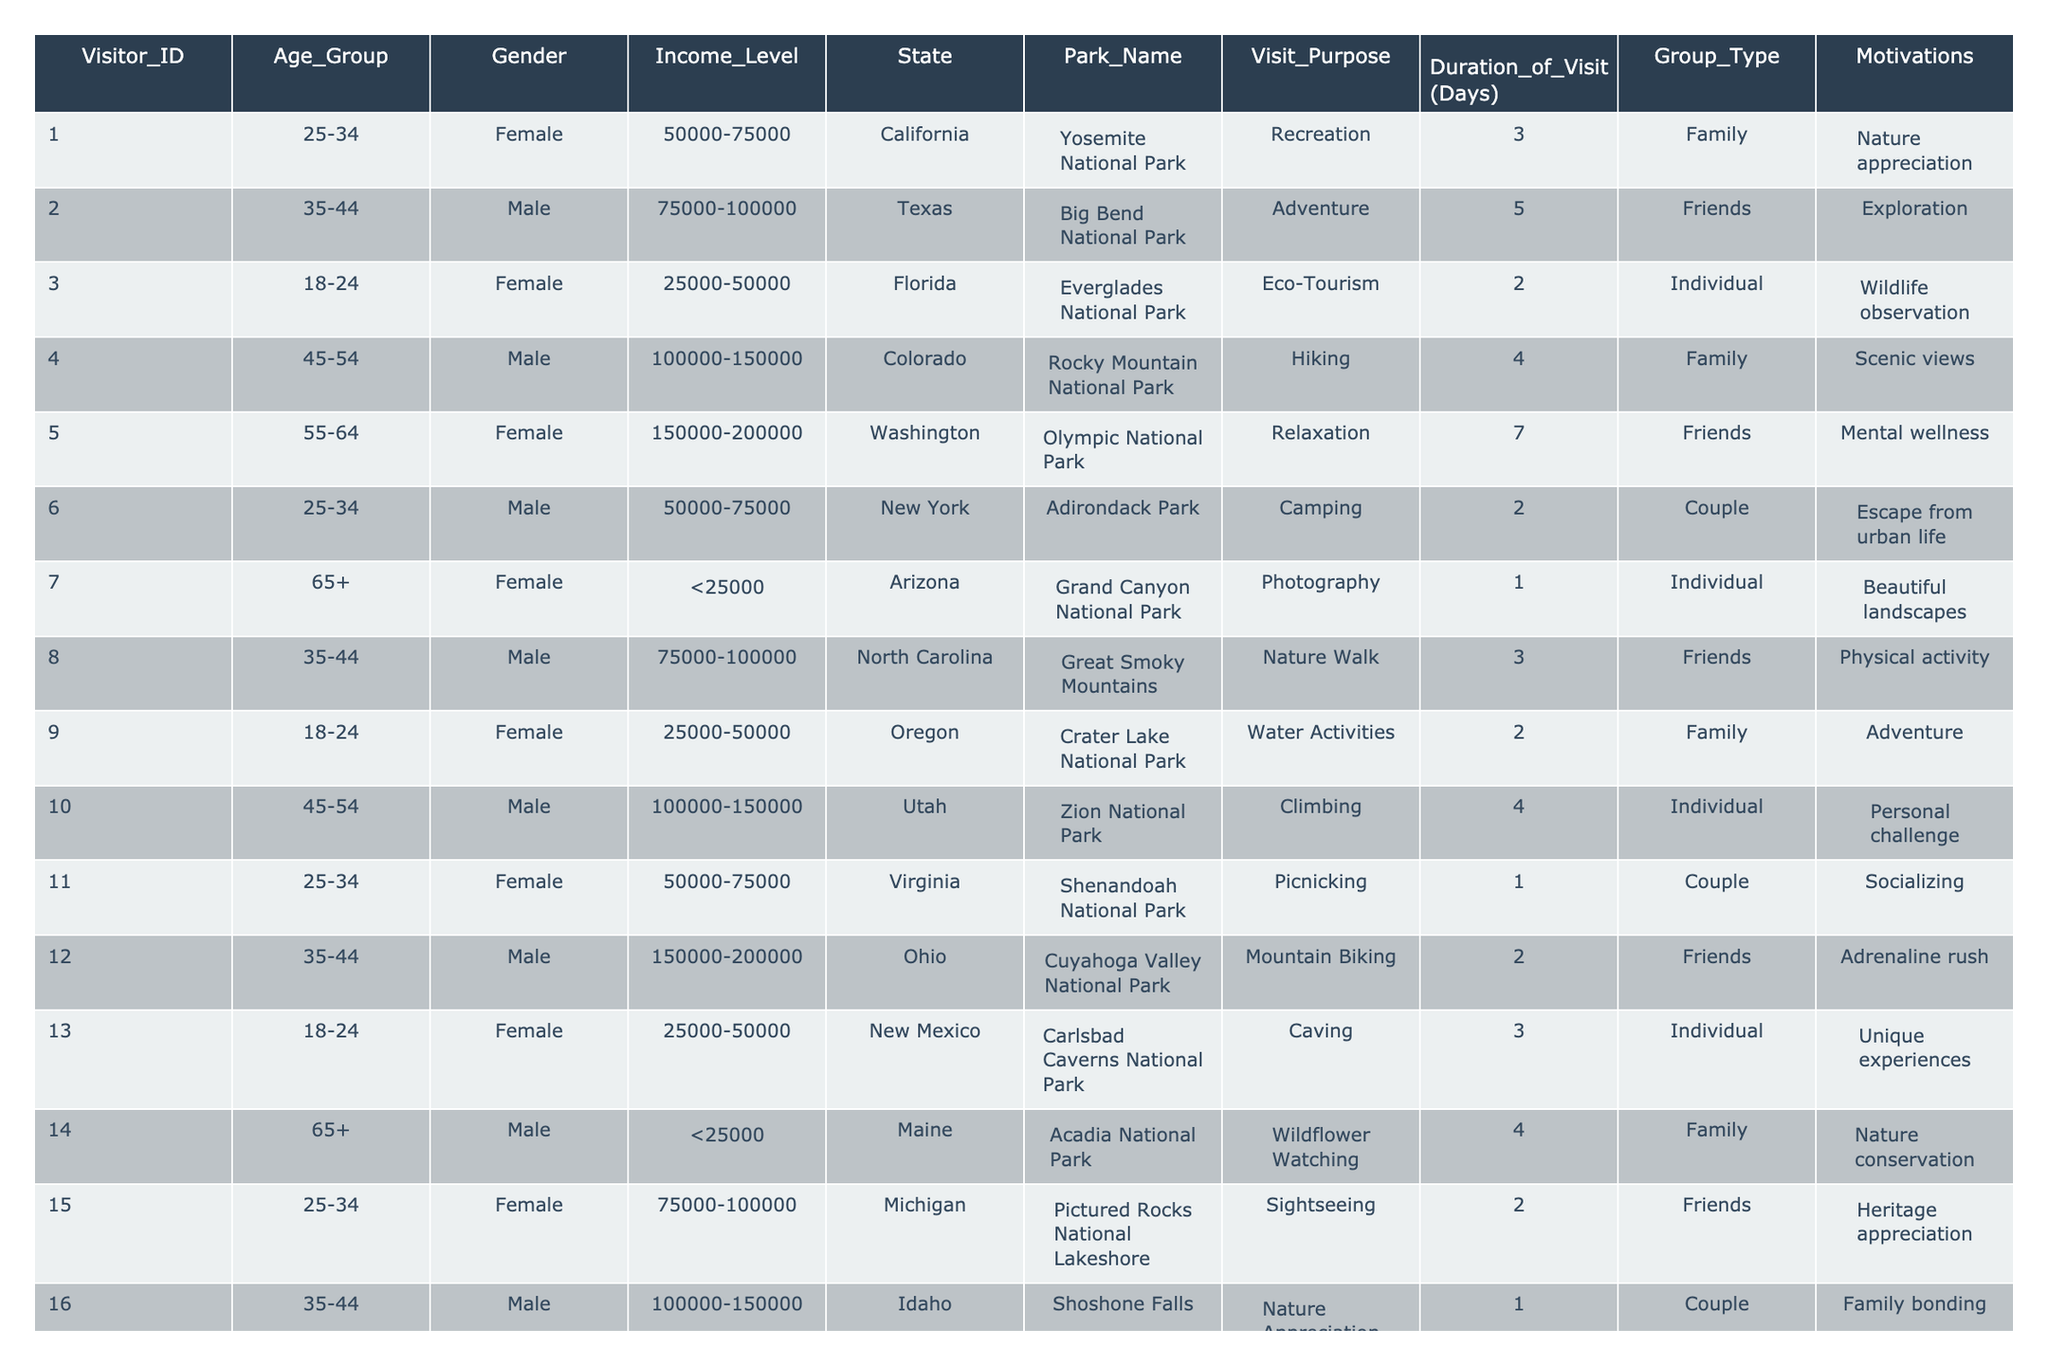What is the most common visit purpose among the visitors? By reviewing the "Visit_Purpose" column, I can count the frequency of each purpose. The visit purposes are: Recreation, Adventure, Eco-Tourism, Hiking, Relaxation, Camping, Photography, Nature Walk, Water Activities, Climbing, Picnicking, Mountain Biking, Caving, Wildflower Watching, Sightseeing, Nature Appreciation, Beach Recreation, Wildlife Watching, and Scenic Drive. The most repeated purpose is Recreation with 4 occurrences.
Answer: Recreation How many visitors came for relaxation? To find this, I will count how many times "Relaxation" appears in the "Visit_Purpose" column. Upon checking, it appears twice in the data set.
Answer: 2 What is the average duration of visits by age group? I will sum the "Duration_of_Visit" for each age group and then divide by the number of visitors in each group. The calculations are as follows: 25-34: (3 + 2 + 1) / 3 = 2; 35-44: (5 + 3 + 2) / 3 = 3.33; 18-24: (2 + 3 + 5) / 3 = 3.33; 45-54: (4 + 2) / 2 = 3; 55-64: (7 + 3) / 2 = 5; 65+: (1 + 4 + 1) / 3 = 2.
Answer: 5 (for 55-64) Is female participation higher than male participation in the data? To answer this, I'll count the number of Female and Male entries in the "Gender" column. There are 10 females and 10 males, so female participation is equal to male participation.
Answer: No How many visitors participating in adventure came from Texas? I will look at the "State" and "Visit_Purpose" columns to find entries where the state is Texas and the purpose is Adventure. There is one such entry, Visitor ID 2.
Answer: 1 Which park was visited for eco-tourism and by whom? I'll search through the "Park_Name" and "Visit_Purpose" columns for the purpose of Eco-Tourism. The entry for Eco-Tourism corresponds to Visitor ID 3, who visited Everglades National Park.
Answer: Everglades National Park, Visitor ID 3 What percentage of male visitors participated in activities related to physical activity? To find the percentage, count the male visitors in "Visit_Purpose" related to physical activity, which is only "Nature Walk." There are 10 males total, and 1 is participating in a physical activity type visit, so (1/10)*100 = 10%.
Answer: 10% What is the relationship between income level and visit purpose? This requires comparing the "Income_Level" and "Visit_Purpose" columns. Each income level corresponds to various visit purposes, with no evident pattern. Most visitors across different income levels chose a recreational purpose, while adventure activities were prevalent among higher income levels. Any conclusions drawn depend on observing the data directly, particularly that nature-related purposes appear more frequently among lower income levels.
Answer: No clear relationship 